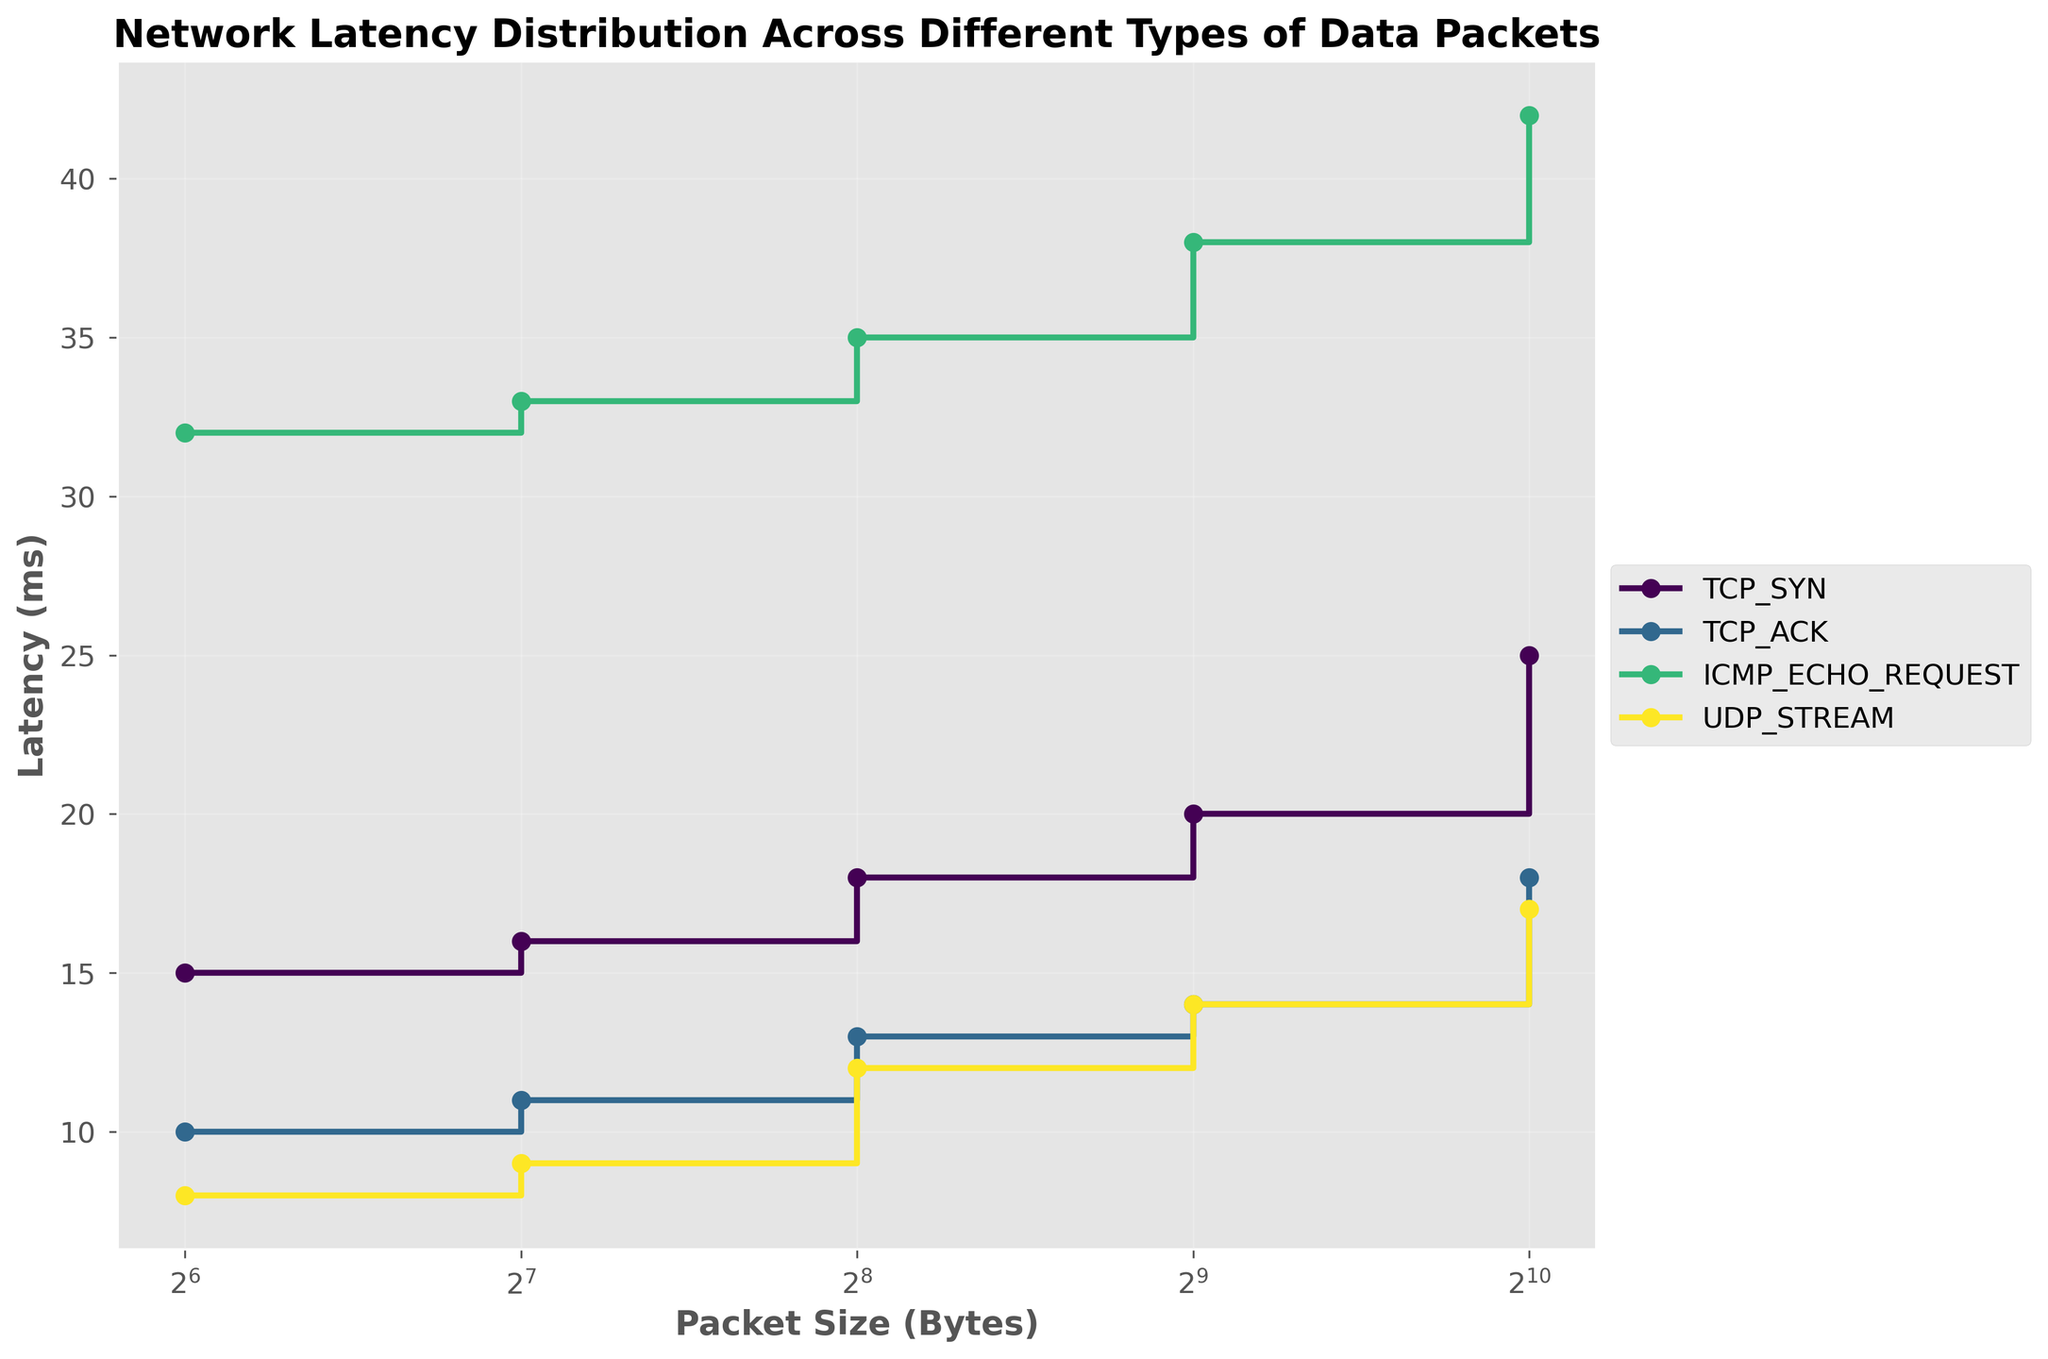What is the title of the plot? The title of the plot is shown at the top, clearly stating the purpose of the visualization.
Answer: Network Latency Distribution Across Different Types of Data Packets Which packet type has the highest latency for the smallest packet size? By examining the leftmost points of the stair steps, the packet type with the highest latency for 64-byte packets can be identified.
Answer: ICMP_ECHO_REQUEST What is the latency for TCP_ACK packets at 512 bytes? By following the TCP_ACK step-line to the 512-byte mark, we can see the corresponding latency value.
Answer: 14 ms For 1024-byte packets, which packet type exhibits the lowest latency? Look at the rightmost points for all stair steps and identify the packet type with the lowest latency value.
Answer: UDP_STREAM What is the difference in latency between TCP_SYN and UDP_STREAM for 64-byte packets? Locate the latency values for TCP_SYN and UDP_STREAM at 64 bytes and subtract the smaller value from the larger one.
Answer: 7 ms Which packet type shows the steepest increase in latency between 64 and 128 bytes? Compare the slopes of the steps between 64 and 128 bytes for all packet types to determine the steepest one.
Answer: ICMP_ECHO_REQUEST What is the average latency of ICMP_ECHO_REQUEST packets across all packet sizes? Sum the latencies for ICMP_ECHO_REQUEST at all packet sizes and divide by the number of data points (5). (32+33+35+38+42)/5 = 180/5
Answer: 36 ms How does the latency of TCP_SYN packets at 1024 bytes compare to TCP_ACK packets at the same size? Check the latency values for both TCP_SYN and TCP_ACK at 1024 bytes and compare which is higher.
Answer: TCP_SYN is higher Which packet type consistently has the lowest latency across all packet sizes? Examine all steps and identify the packet type that remains below others consistently.
Answer: UDP_STREAM At what packet size do TCP_SYN and TCP_ACK have the same latency? Find the packet size where the latency steps of TCP_SYN and TCP_ACK intersect.
Answer: They do not intersect, no size 